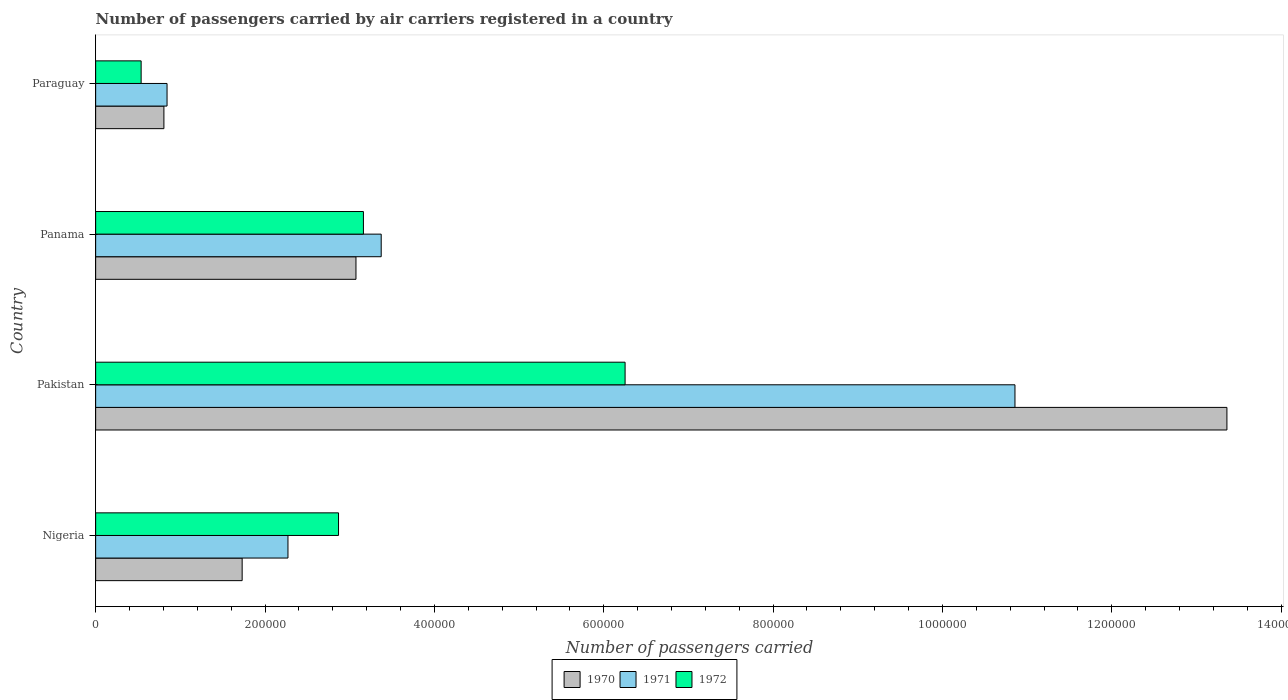How many different coloured bars are there?
Offer a very short reply. 3. Are the number of bars on each tick of the Y-axis equal?
Keep it short and to the point. Yes. How many bars are there on the 4th tick from the bottom?
Your answer should be compact. 3. What is the number of passengers carried by air carriers in 1972 in Pakistan?
Your response must be concise. 6.25e+05. Across all countries, what is the maximum number of passengers carried by air carriers in 1972?
Make the answer very short. 6.25e+05. Across all countries, what is the minimum number of passengers carried by air carriers in 1971?
Give a very brief answer. 8.43e+04. In which country was the number of passengers carried by air carriers in 1971 maximum?
Provide a short and direct response. Pakistan. In which country was the number of passengers carried by air carriers in 1972 minimum?
Offer a terse response. Paraguay. What is the total number of passengers carried by air carriers in 1972 in the graph?
Give a very brief answer. 1.28e+06. What is the difference between the number of passengers carried by air carriers in 1972 in Nigeria and that in Paraguay?
Provide a succinct answer. 2.33e+05. What is the difference between the number of passengers carried by air carriers in 1971 in Panama and the number of passengers carried by air carriers in 1970 in Pakistan?
Make the answer very short. -9.99e+05. What is the average number of passengers carried by air carriers in 1972 per country?
Your answer should be very brief. 3.20e+05. What is the difference between the number of passengers carried by air carriers in 1970 and number of passengers carried by air carriers in 1971 in Panama?
Provide a short and direct response. -2.98e+04. What is the ratio of the number of passengers carried by air carriers in 1972 in Nigeria to that in Panama?
Keep it short and to the point. 0.91. What is the difference between the highest and the second highest number of passengers carried by air carriers in 1970?
Provide a succinct answer. 1.03e+06. What is the difference between the highest and the lowest number of passengers carried by air carriers in 1971?
Provide a short and direct response. 1.00e+06. What does the 3rd bar from the bottom in Paraguay represents?
Keep it short and to the point. 1972. How many bars are there?
Your answer should be very brief. 12. Are all the bars in the graph horizontal?
Provide a succinct answer. Yes. How many countries are there in the graph?
Give a very brief answer. 4. What is the difference between two consecutive major ticks on the X-axis?
Provide a short and direct response. 2.00e+05. Where does the legend appear in the graph?
Ensure brevity in your answer.  Bottom center. How are the legend labels stacked?
Provide a succinct answer. Horizontal. What is the title of the graph?
Offer a very short reply. Number of passengers carried by air carriers registered in a country. Does "2004" appear as one of the legend labels in the graph?
Your answer should be compact. No. What is the label or title of the X-axis?
Provide a short and direct response. Number of passengers carried. What is the Number of passengers carried of 1970 in Nigeria?
Your answer should be very brief. 1.73e+05. What is the Number of passengers carried of 1971 in Nigeria?
Keep it short and to the point. 2.27e+05. What is the Number of passengers carried in 1972 in Nigeria?
Offer a very short reply. 2.87e+05. What is the Number of passengers carried in 1970 in Pakistan?
Your answer should be compact. 1.34e+06. What is the Number of passengers carried of 1971 in Pakistan?
Make the answer very short. 1.09e+06. What is the Number of passengers carried in 1972 in Pakistan?
Your response must be concise. 6.25e+05. What is the Number of passengers carried in 1970 in Panama?
Offer a terse response. 3.07e+05. What is the Number of passengers carried of 1971 in Panama?
Your answer should be compact. 3.37e+05. What is the Number of passengers carried of 1972 in Panama?
Make the answer very short. 3.16e+05. What is the Number of passengers carried in 1970 in Paraguay?
Give a very brief answer. 8.06e+04. What is the Number of passengers carried of 1971 in Paraguay?
Provide a short and direct response. 8.43e+04. What is the Number of passengers carried in 1972 in Paraguay?
Give a very brief answer. 5.37e+04. Across all countries, what is the maximum Number of passengers carried in 1970?
Provide a short and direct response. 1.34e+06. Across all countries, what is the maximum Number of passengers carried in 1971?
Keep it short and to the point. 1.09e+06. Across all countries, what is the maximum Number of passengers carried in 1972?
Your response must be concise. 6.25e+05. Across all countries, what is the minimum Number of passengers carried of 1970?
Provide a short and direct response. 8.06e+04. Across all countries, what is the minimum Number of passengers carried in 1971?
Keep it short and to the point. 8.43e+04. Across all countries, what is the minimum Number of passengers carried of 1972?
Ensure brevity in your answer.  5.37e+04. What is the total Number of passengers carried of 1970 in the graph?
Your response must be concise. 1.90e+06. What is the total Number of passengers carried of 1971 in the graph?
Provide a succinct answer. 1.73e+06. What is the total Number of passengers carried in 1972 in the graph?
Make the answer very short. 1.28e+06. What is the difference between the Number of passengers carried of 1970 in Nigeria and that in Pakistan?
Make the answer very short. -1.16e+06. What is the difference between the Number of passengers carried in 1971 in Nigeria and that in Pakistan?
Your answer should be compact. -8.58e+05. What is the difference between the Number of passengers carried of 1972 in Nigeria and that in Pakistan?
Provide a short and direct response. -3.38e+05. What is the difference between the Number of passengers carried of 1970 in Nigeria and that in Panama?
Keep it short and to the point. -1.34e+05. What is the difference between the Number of passengers carried of 1971 in Nigeria and that in Panama?
Your response must be concise. -1.10e+05. What is the difference between the Number of passengers carried in 1972 in Nigeria and that in Panama?
Your answer should be very brief. -2.94e+04. What is the difference between the Number of passengers carried of 1970 in Nigeria and that in Paraguay?
Provide a succinct answer. 9.24e+04. What is the difference between the Number of passengers carried of 1971 in Nigeria and that in Paraguay?
Offer a very short reply. 1.43e+05. What is the difference between the Number of passengers carried in 1972 in Nigeria and that in Paraguay?
Make the answer very short. 2.33e+05. What is the difference between the Number of passengers carried of 1970 in Pakistan and that in Panama?
Offer a very short reply. 1.03e+06. What is the difference between the Number of passengers carried in 1971 in Pakistan and that in Panama?
Keep it short and to the point. 7.48e+05. What is the difference between the Number of passengers carried of 1972 in Pakistan and that in Panama?
Your answer should be very brief. 3.09e+05. What is the difference between the Number of passengers carried of 1970 in Pakistan and that in Paraguay?
Provide a short and direct response. 1.26e+06. What is the difference between the Number of passengers carried of 1971 in Pakistan and that in Paraguay?
Give a very brief answer. 1.00e+06. What is the difference between the Number of passengers carried of 1972 in Pakistan and that in Paraguay?
Keep it short and to the point. 5.72e+05. What is the difference between the Number of passengers carried of 1970 in Panama and that in Paraguay?
Provide a succinct answer. 2.27e+05. What is the difference between the Number of passengers carried in 1971 in Panama and that in Paraguay?
Provide a succinct answer. 2.53e+05. What is the difference between the Number of passengers carried of 1972 in Panama and that in Paraguay?
Offer a terse response. 2.62e+05. What is the difference between the Number of passengers carried of 1970 in Nigeria and the Number of passengers carried of 1971 in Pakistan?
Ensure brevity in your answer.  -9.13e+05. What is the difference between the Number of passengers carried in 1970 in Nigeria and the Number of passengers carried in 1972 in Pakistan?
Give a very brief answer. -4.52e+05. What is the difference between the Number of passengers carried in 1971 in Nigeria and the Number of passengers carried in 1972 in Pakistan?
Keep it short and to the point. -3.98e+05. What is the difference between the Number of passengers carried in 1970 in Nigeria and the Number of passengers carried in 1971 in Panama?
Your answer should be very brief. -1.64e+05. What is the difference between the Number of passengers carried of 1970 in Nigeria and the Number of passengers carried of 1972 in Panama?
Your response must be concise. -1.43e+05. What is the difference between the Number of passengers carried in 1971 in Nigeria and the Number of passengers carried in 1972 in Panama?
Provide a succinct answer. -8.91e+04. What is the difference between the Number of passengers carried in 1970 in Nigeria and the Number of passengers carried in 1971 in Paraguay?
Make the answer very short. 8.87e+04. What is the difference between the Number of passengers carried in 1970 in Nigeria and the Number of passengers carried in 1972 in Paraguay?
Offer a very short reply. 1.19e+05. What is the difference between the Number of passengers carried of 1971 in Nigeria and the Number of passengers carried of 1972 in Paraguay?
Ensure brevity in your answer.  1.73e+05. What is the difference between the Number of passengers carried in 1970 in Pakistan and the Number of passengers carried in 1971 in Panama?
Offer a terse response. 9.99e+05. What is the difference between the Number of passengers carried in 1970 in Pakistan and the Number of passengers carried in 1972 in Panama?
Your answer should be compact. 1.02e+06. What is the difference between the Number of passengers carried in 1971 in Pakistan and the Number of passengers carried in 1972 in Panama?
Offer a very short reply. 7.69e+05. What is the difference between the Number of passengers carried of 1970 in Pakistan and the Number of passengers carried of 1971 in Paraguay?
Offer a terse response. 1.25e+06. What is the difference between the Number of passengers carried in 1970 in Pakistan and the Number of passengers carried in 1972 in Paraguay?
Offer a very short reply. 1.28e+06. What is the difference between the Number of passengers carried of 1971 in Pakistan and the Number of passengers carried of 1972 in Paraguay?
Your response must be concise. 1.03e+06. What is the difference between the Number of passengers carried of 1970 in Panama and the Number of passengers carried of 1971 in Paraguay?
Provide a short and direct response. 2.23e+05. What is the difference between the Number of passengers carried in 1970 in Panama and the Number of passengers carried in 1972 in Paraguay?
Provide a short and direct response. 2.54e+05. What is the difference between the Number of passengers carried in 1971 in Panama and the Number of passengers carried in 1972 in Paraguay?
Keep it short and to the point. 2.84e+05. What is the average Number of passengers carried in 1970 per country?
Offer a terse response. 4.74e+05. What is the average Number of passengers carried in 1971 per country?
Provide a short and direct response. 4.34e+05. What is the average Number of passengers carried of 1972 per country?
Ensure brevity in your answer.  3.20e+05. What is the difference between the Number of passengers carried of 1970 and Number of passengers carried of 1971 in Nigeria?
Offer a terse response. -5.41e+04. What is the difference between the Number of passengers carried in 1970 and Number of passengers carried in 1972 in Nigeria?
Make the answer very short. -1.14e+05. What is the difference between the Number of passengers carried in 1971 and Number of passengers carried in 1972 in Nigeria?
Give a very brief answer. -5.97e+04. What is the difference between the Number of passengers carried of 1970 and Number of passengers carried of 1971 in Pakistan?
Provide a short and direct response. 2.50e+05. What is the difference between the Number of passengers carried of 1970 and Number of passengers carried of 1972 in Pakistan?
Your answer should be compact. 7.11e+05. What is the difference between the Number of passengers carried in 1971 and Number of passengers carried in 1972 in Pakistan?
Provide a succinct answer. 4.60e+05. What is the difference between the Number of passengers carried in 1970 and Number of passengers carried in 1971 in Panama?
Provide a succinct answer. -2.98e+04. What is the difference between the Number of passengers carried in 1970 and Number of passengers carried in 1972 in Panama?
Offer a very short reply. -8800. What is the difference between the Number of passengers carried in 1971 and Number of passengers carried in 1972 in Panama?
Make the answer very short. 2.10e+04. What is the difference between the Number of passengers carried of 1970 and Number of passengers carried of 1971 in Paraguay?
Your response must be concise. -3700. What is the difference between the Number of passengers carried in 1970 and Number of passengers carried in 1972 in Paraguay?
Offer a very short reply. 2.69e+04. What is the difference between the Number of passengers carried of 1971 and Number of passengers carried of 1972 in Paraguay?
Your response must be concise. 3.06e+04. What is the ratio of the Number of passengers carried of 1970 in Nigeria to that in Pakistan?
Offer a terse response. 0.13. What is the ratio of the Number of passengers carried in 1971 in Nigeria to that in Pakistan?
Your answer should be compact. 0.21. What is the ratio of the Number of passengers carried in 1972 in Nigeria to that in Pakistan?
Offer a very short reply. 0.46. What is the ratio of the Number of passengers carried in 1970 in Nigeria to that in Panama?
Provide a succinct answer. 0.56. What is the ratio of the Number of passengers carried in 1971 in Nigeria to that in Panama?
Provide a short and direct response. 0.67. What is the ratio of the Number of passengers carried of 1972 in Nigeria to that in Panama?
Keep it short and to the point. 0.91. What is the ratio of the Number of passengers carried of 1970 in Nigeria to that in Paraguay?
Your answer should be very brief. 2.15. What is the ratio of the Number of passengers carried in 1971 in Nigeria to that in Paraguay?
Your response must be concise. 2.69. What is the ratio of the Number of passengers carried of 1972 in Nigeria to that in Paraguay?
Give a very brief answer. 5.34. What is the ratio of the Number of passengers carried of 1970 in Pakistan to that in Panama?
Ensure brevity in your answer.  4.35. What is the ratio of the Number of passengers carried in 1971 in Pakistan to that in Panama?
Make the answer very short. 3.22. What is the ratio of the Number of passengers carried of 1972 in Pakistan to that in Panama?
Offer a terse response. 1.98. What is the ratio of the Number of passengers carried in 1970 in Pakistan to that in Paraguay?
Ensure brevity in your answer.  16.57. What is the ratio of the Number of passengers carried in 1971 in Pakistan to that in Paraguay?
Provide a short and direct response. 12.88. What is the ratio of the Number of passengers carried in 1972 in Pakistan to that in Paraguay?
Your answer should be compact. 11.64. What is the ratio of the Number of passengers carried of 1970 in Panama to that in Paraguay?
Keep it short and to the point. 3.81. What is the ratio of the Number of passengers carried of 1972 in Panama to that in Paraguay?
Provide a short and direct response. 5.89. What is the difference between the highest and the second highest Number of passengers carried of 1970?
Provide a succinct answer. 1.03e+06. What is the difference between the highest and the second highest Number of passengers carried in 1971?
Make the answer very short. 7.48e+05. What is the difference between the highest and the second highest Number of passengers carried of 1972?
Give a very brief answer. 3.09e+05. What is the difference between the highest and the lowest Number of passengers carried in 1970?
Your response must be concise. 1.26e+06. What is the difference between the highest and the lowest Number of passengers carried in 1971?
Offer a very short reply. 1.00e+06. What is the difference between the highest and the lowest Number of passengers carried in 1972?
Offer a terse response. 5.72e+05. 